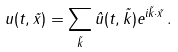<formula> <loc_0><loc_0><loc_500><loc_500>u ( t , \vec { x } ) = \sum _ { \vec { k } } \hat { u } ( t , \vec { k } ) e ^ { i \vec { k } \cdot \vec { x } } \, .</formula> 